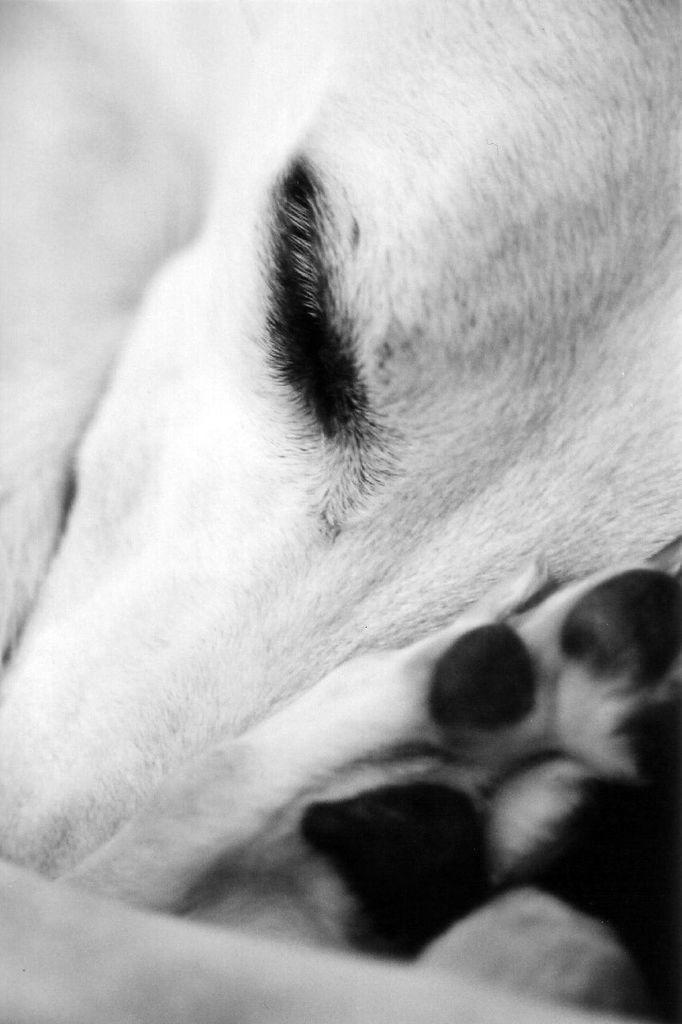Please provide a concise description of this image. In this image I can see an animal and I can also see this image is black and white in colour. 